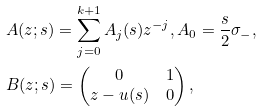<formula> <loc_0><loc_0><loc_500><loc_500>& A ( z ; s ) = \sum _ { j = 0 } ^ { k + 1 } A _ { j } ( s ) z ^ { - j } , A _ { 0 } = \frac { s } { 2 } \sigma _ { - } , \\ & B ( z ; s ) = \begin{pmatrix} 0 & 1 \\ z - u ( s ) & 0 \end{pmatrix} ,</formula> 